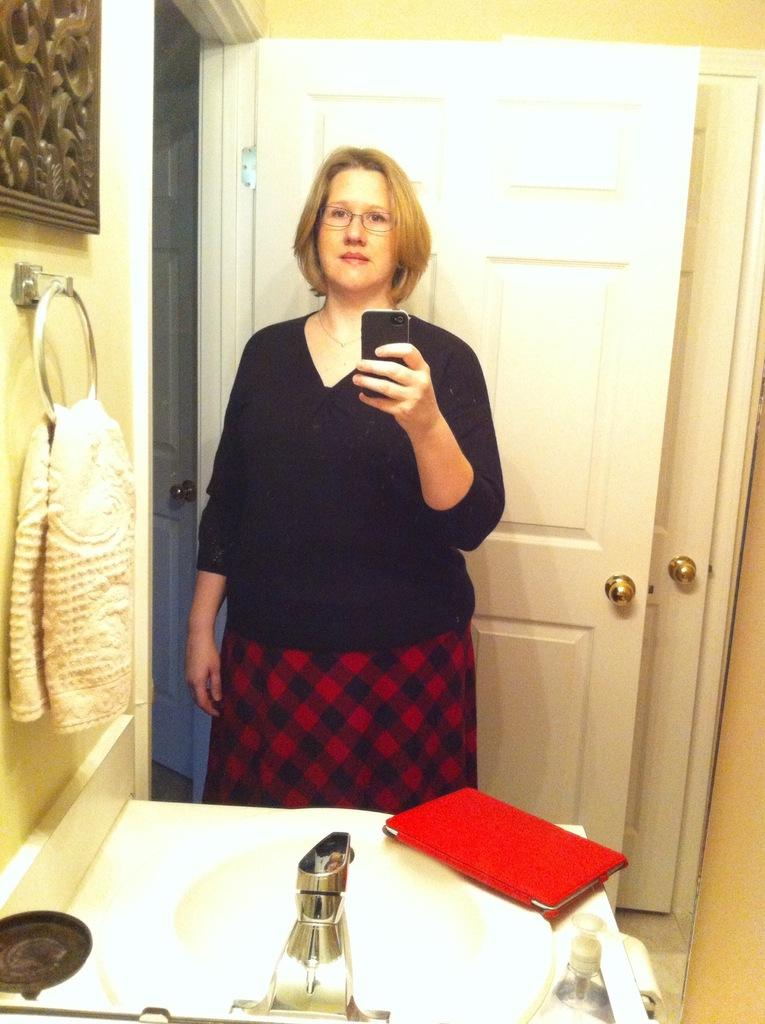Who is present in the image? There is a woman in the image. What is the woman holding? The woman is holding a mobile. What is in front of the woman? There is a sink, a cloth, and other objects in front of the woman. What can be seen in the background of the image? There is a wall and a door in the background of the image. What type of fear can be seen on the woman's face in the image? There is no indication of fear on the woman's face in the image. What event is the woman attending in the image? There is no event depicted in the image; it shows a woman holding a mobile in front of a sink and other objects. 